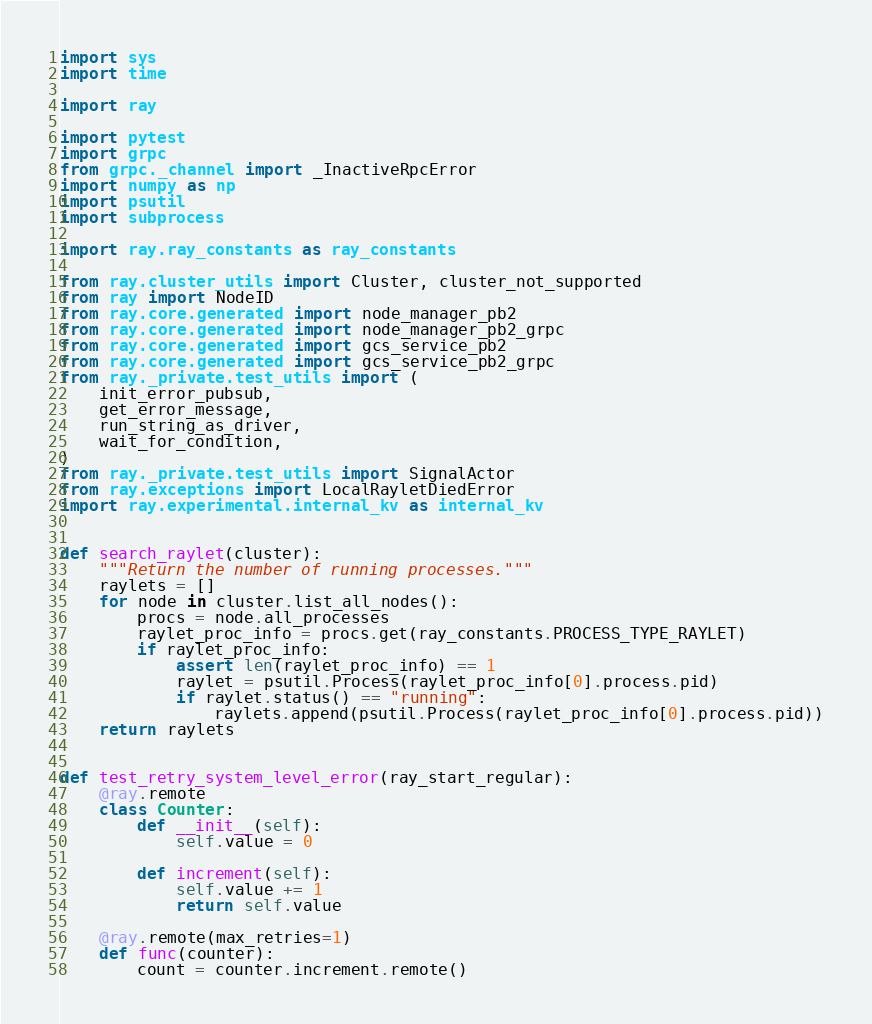<code> <loc_0><loc_0><loc_500><loc_500><_Python_>import sys
import time

import ray

import pytest
import grpc
from grpc._channel import _InactiveRpcError
import numpy as np
import psutil
import subprocess

import ray.ray_constants as ray_constants

from ray.cluster_utils import Cluster, cluster_not_supported
from ray import NodeID
from ray.core.generated import node_manager_pb2
from ray.core.generated import node_manager_pb2_grpc
from ray.core.generated import gcs_service_pb2
from ray.core.generated import gcs_service_pb2_grpc
from ray._private.test_utils import (
    init_error_pubsub,
    get_error_message,
    run_string_as_driver,
    wait_for_condition,
)
from ray._private.test_utils import SignalActor
from ray.exceptions import LocalRayletDiedError
import ray.experimental.internal_kv as internal_kv


def search_raylet(cluster):
    """Return the number of running processes."""
    raylets = []
    for node in cluster.list_all_nodes():
        procs = node.all_processes
        raylet_proc_info = procs.get(ray_constants.PROCESS_TYPE_RAYLET)
        if raylet_proc_info:
            assert len(raylet_proc_info) == 1
            raylet = psutil.Process(raylet_proc_info[0].process.pid)
            if raylet.status() == "running":
                raylets.append(psutil.Process(raylet_proc_info[0].process.pid))
    return raylets


def test_retry_system_level_error(ray_start_regular):
    @ray.remote
    class Counter:
        def __init__(self):
            self.value = 0

        def increment(self):
            self.value += 1
            return self.value

    @ray.remote(max_retries=1)
    def func(counter):
        count = counter.increment.remote()</code> 